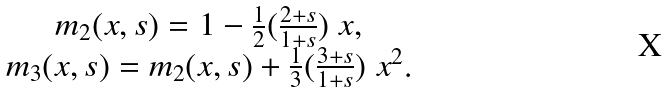Convert formula to latex. <formula><loc_0><loc_0><loc_500><loc_500>\begin{array} { c } m _ { 2 } ( x , s ) = 1 - \frac { 1 } { 2 } ( \frac { 2 + s } { 1 + s } ) \ x , \\ m _ { 3 } ( x , s ) = m _ { 2 } ( x , s ) + \frac { 1 } { 3 } ( \frac { 3 + s } { 1 + s } ) \ x ^ { 2 } . \end{array}</formula> 